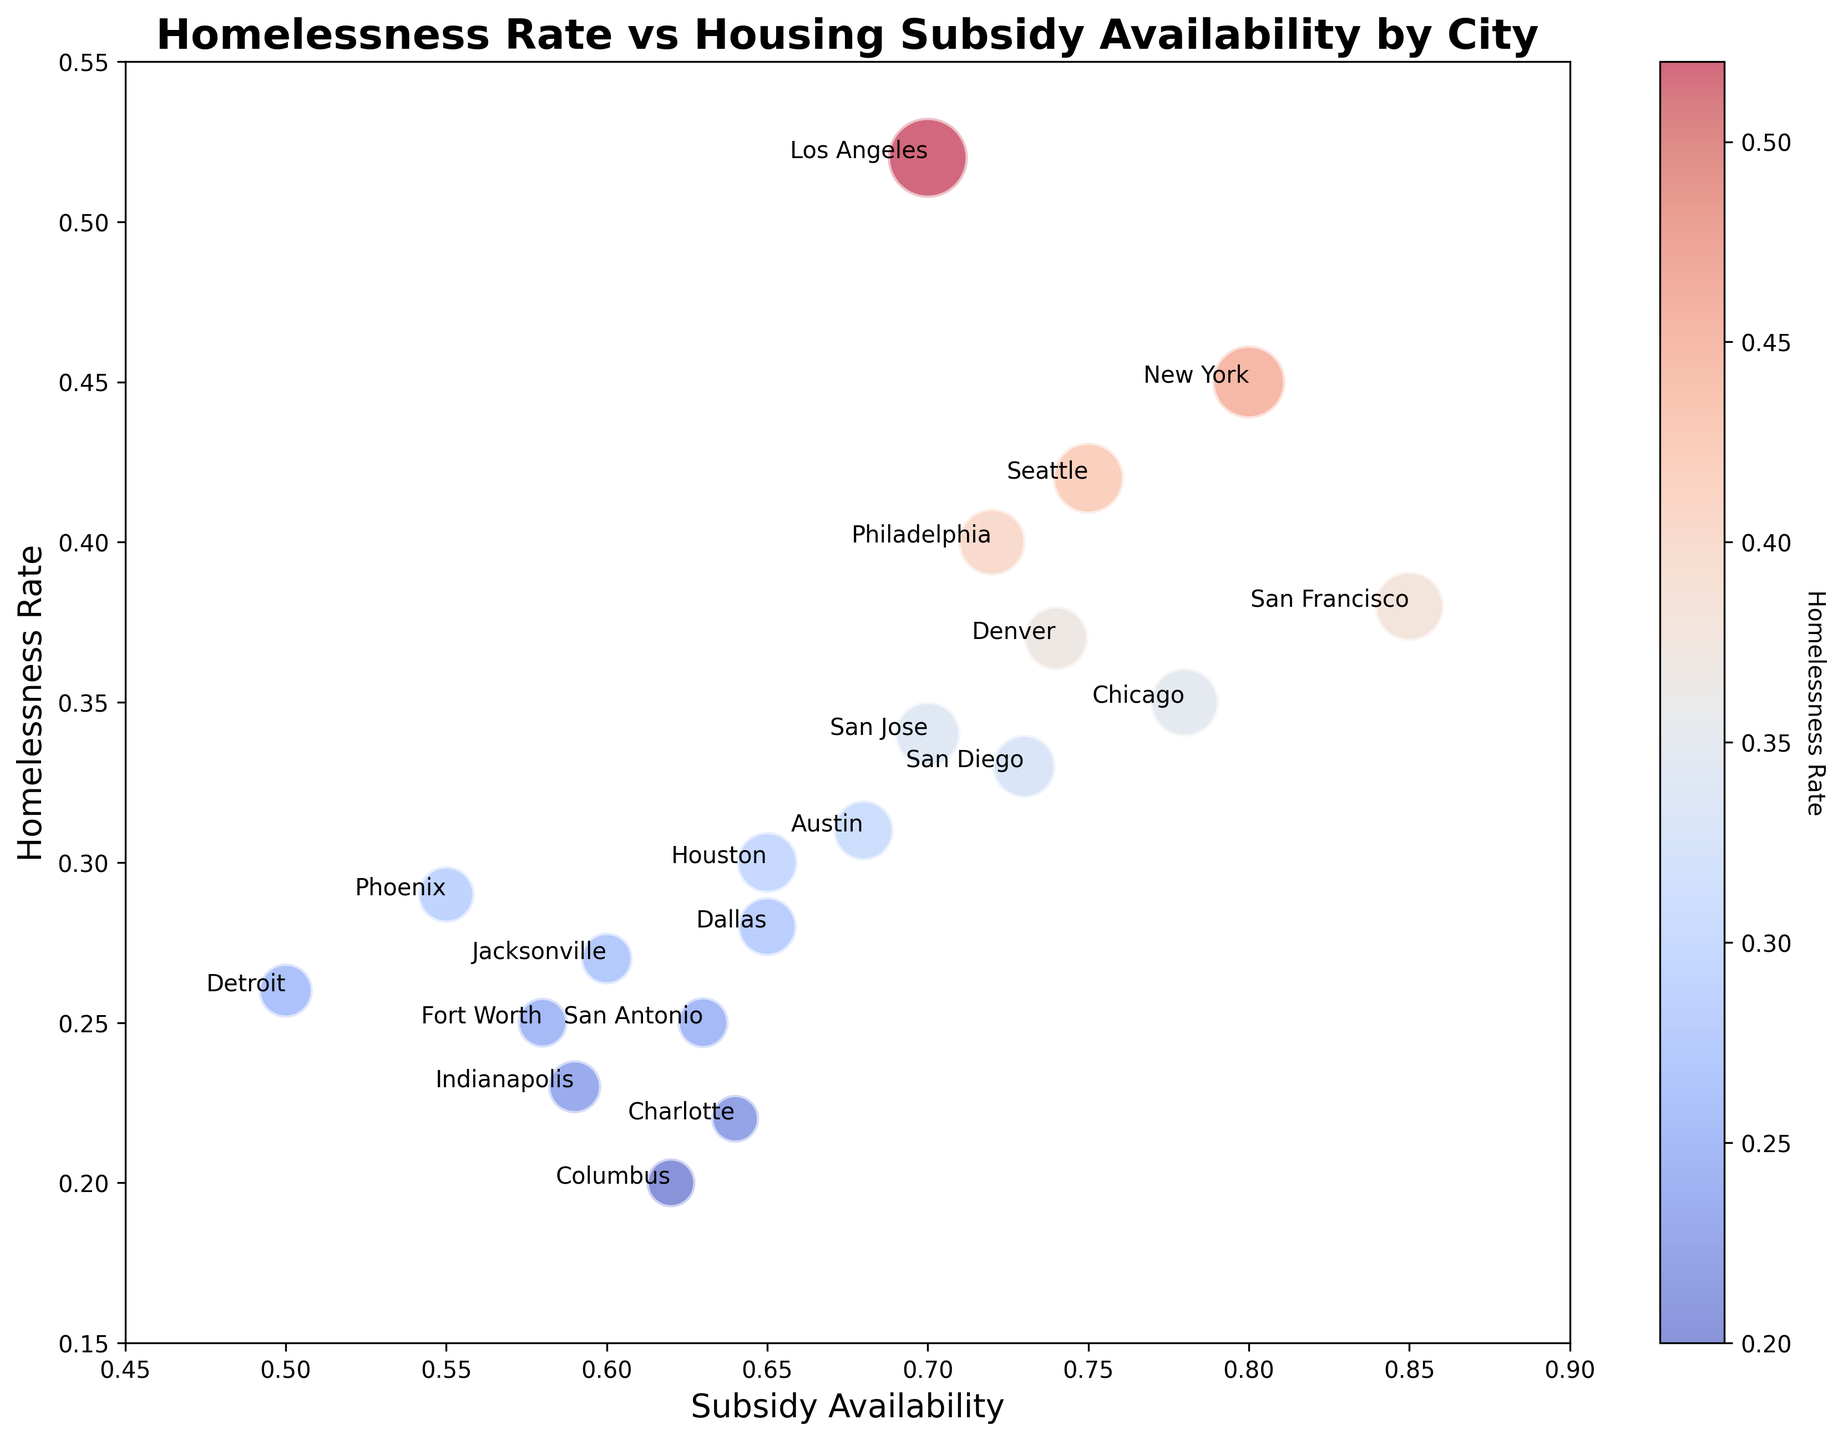Which city has the highest homelessness rate? By looking at the "Homelessness Rate" values on the figure, the city with the highest value needs to be identified. Los Angeles has the highest homelessness rate of 0.52.
Answer: Los Angeles What is the homelessness rate for Houston compared to Phoenix? Locate Houston and Phoenix in the plot and compare the "Homelessness Rate" values. Houston has a rate of 0.30 and Phoenix has a rate of 0.29, so Houston's rate is slightly higher.
Answer: Houston: 0.30, Phoenix: 0.29 Which city has the lowest housing subsidy availability? Find the city with the lowest "Subsidy Availability" value in the figure, which is Detroit with a value of 0.50.
Answer: Detroit What are the cities with a homelessness rate greater than 0.40? Identify the cities with "Homelessness Rate" values greater than 0.40 in the figure: New York, Los Angeles, Seattle, Philadelphia, and Denver.
Answer: New York, Los Angeles, Seattle, Philadelphia, Denver What is the pattern between homelessness rate and subsidy availability in the figure? Observe the overall trend in the bubble chart. Cities with lower housing subsidy availability tend to have lower homelessness rates, and those with higher housing subsidy availability have varying homelessness rates, indicating a non-linear relationship.
Answer: Non-linear relationship What is the average homelessness rate for cities with subsidy availability below 0.7? Average the "Homelessness Rate" for cities with "Subsidy Availability" less than 0.7: Houston (0.30), Phoenix (0.29), Dallas (0.28), Jacksonville (0.27), Fort Worth (0.25), San Antonio (0.25), Detroit (0.26), Indianapolis (0.23), Columbus (0.20), and Charlotte (0.22). The average: (0.30+0.29+0.28+0.27+0.25+0.25+0.26+0.23+0.20+0.22) / 10 = 0.255.
Answer: 0.255 Which city has the largest bubble size, and what does this signify? Identify the city with the largest bubble size in the figure: Los Angeles with a bubble size of 120. This represents a higher overall impact or population considering the homelessness rate and subsidy availability.
Answer: Los Angeles, high impact Compare the homelessness rates and subsidy availabilities of San Francisco and Denver. San Francisco has a homelessness rate of 0.38 and subsidy availability of 0.85. Denver has a homelessness rate of 0.37 and subsidy availability of 0.74. Therefore, San Francisco has a slightly higher subsidy availability, and both have similar homelessness rates.
Answer: San Francisco: 0.38, 0.85; Denver: 0.37, 0.74 What is the total bubble size of cities with homelessness rates above 0.40? Sum the "Bubble_Size" for cities with "Homelessness Rate" above 0.40: New York (100), Los Angeles (120), Seattle (95), Philadelphia (85), Denver (77). The total size: 100 + 120 + 95 + 85 + 77 = 477.
Answer: 477 How does the homelessness rate in Chicago compare to Austin? Look at the "Homelessness Rate" values for Chicago (0.35) and Austin (0.31); Chicago has a higher homelessness rate than Austin.
Answer: Chicago: 0.35, Austin: 0.31 